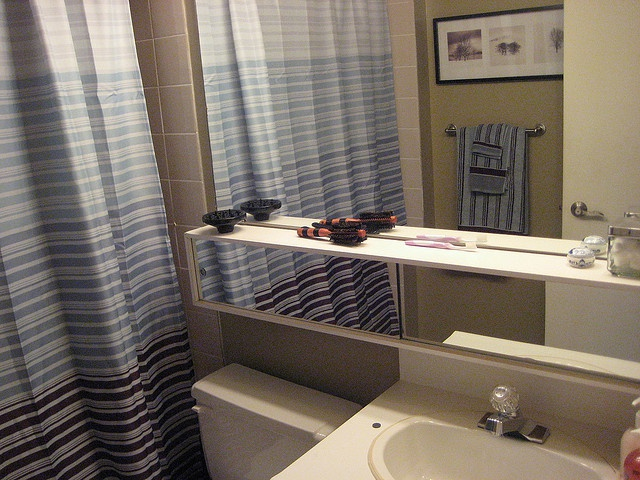Describe the objects in this image and their specific colors. I can see toilet in gray and tan tones, sink in gray and tan tones, bottle in gray, tan, and darkgray tones, toothbrush in gray, lightgray, lightpink, tan, and pink tones, and toothbrush in gray, ivory, lightpink, and tan tones in this image. 